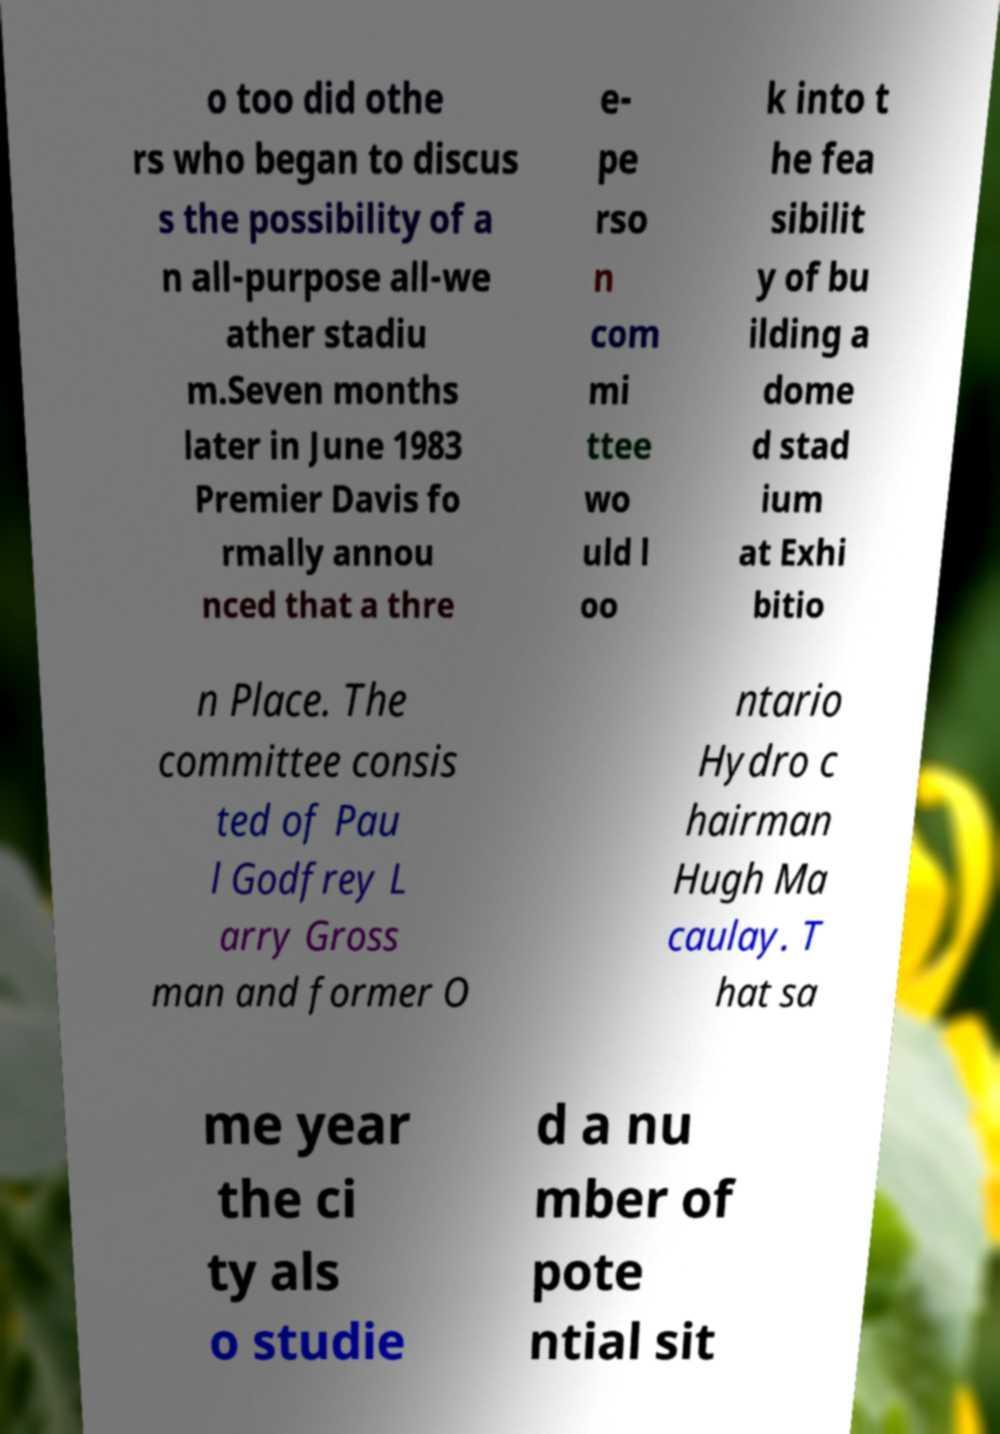Please identify and transcribe the text found in this image. o too did othe rs who began to discus s the possibility of a n all-purpose all-we ather stadiu m.Seven months later in June 1983 Premier Davis fo rmally annou nced that a thre e- pe rso n com mi ttee wo uld l oo k into t he fea sibilit y of bu ilding a dome d stad ium at Exhi bitio n Place. The committee consis ted of Pau l Godfrey L arry Gross man and former O ntario Hydro c hairman Hugh Ma caulay. T hat sa me year the ci ty als o studie d a nu mber of pote ntial sit 